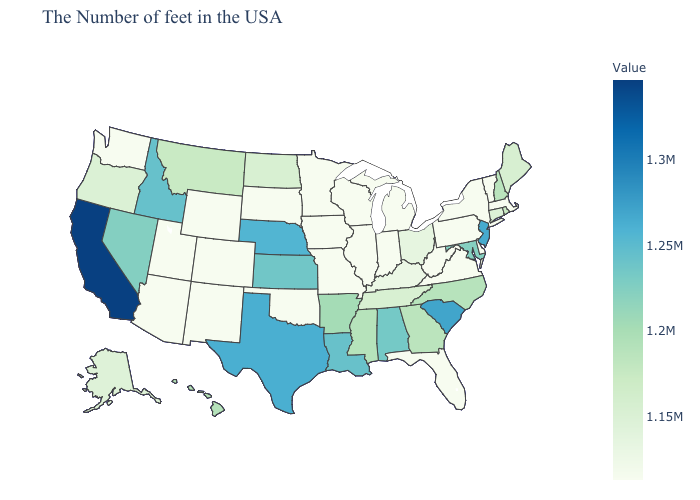Which states have the highest value in the USA?
Keep it brief. California. Which states have the lowest value in the South?
Give a very brief answer. Delaware, Virginia, West Virginia, Florida, Oklahoma. 